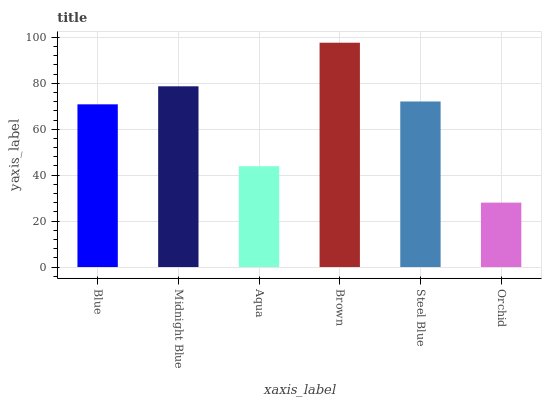Is Midnight Blue the minimum?
Answer yes or no. No. Is Midnight Blue the maximum?
Answer yes or no. No. Is Midnight Blue greater than Blue?
Answer yes or no. Yes. Is Blue less than Midnight Blue?
Answer yes or no. Yes. Is Blue greater than Midnight Blue?
Answer yes or no. No. Is Midnight Blue less than Blue?
Answer yes or no. No. Is Steel Blue the high median?
Answer yes or no. Yes. Is Blue the low median?
Answer yes or no. Yes. Is Blue the high median?
Answer yes or no. No. Is Aqua the low median?
Answer yes or no. No. 